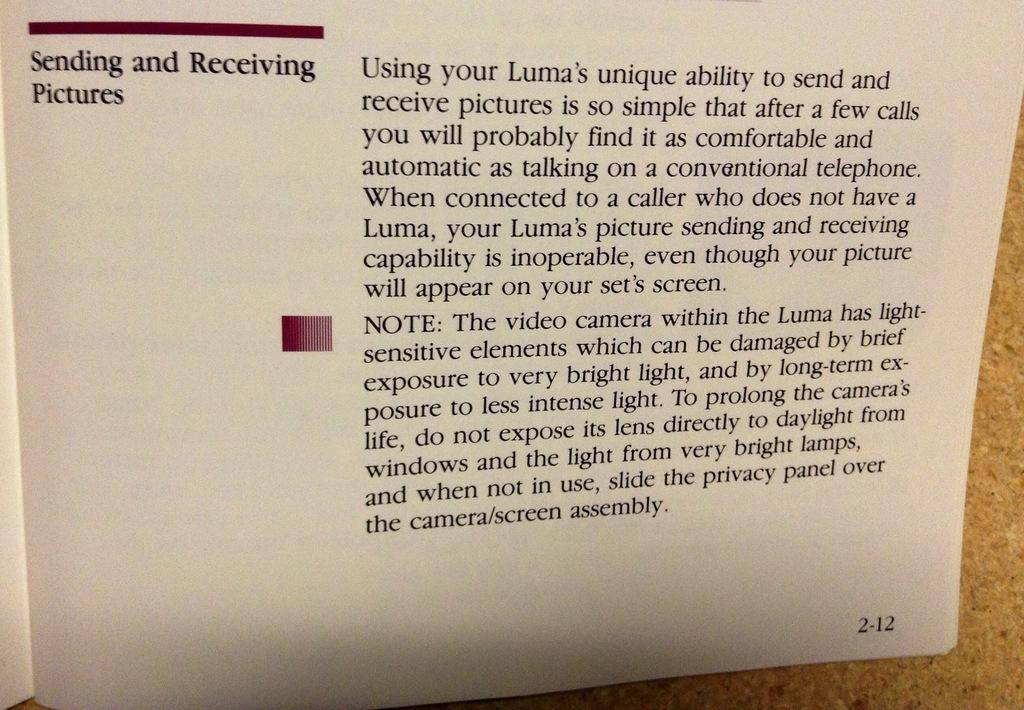<image>
Relay a brief, clear account of the picture shown. A book about sending pictures is open to page 212 